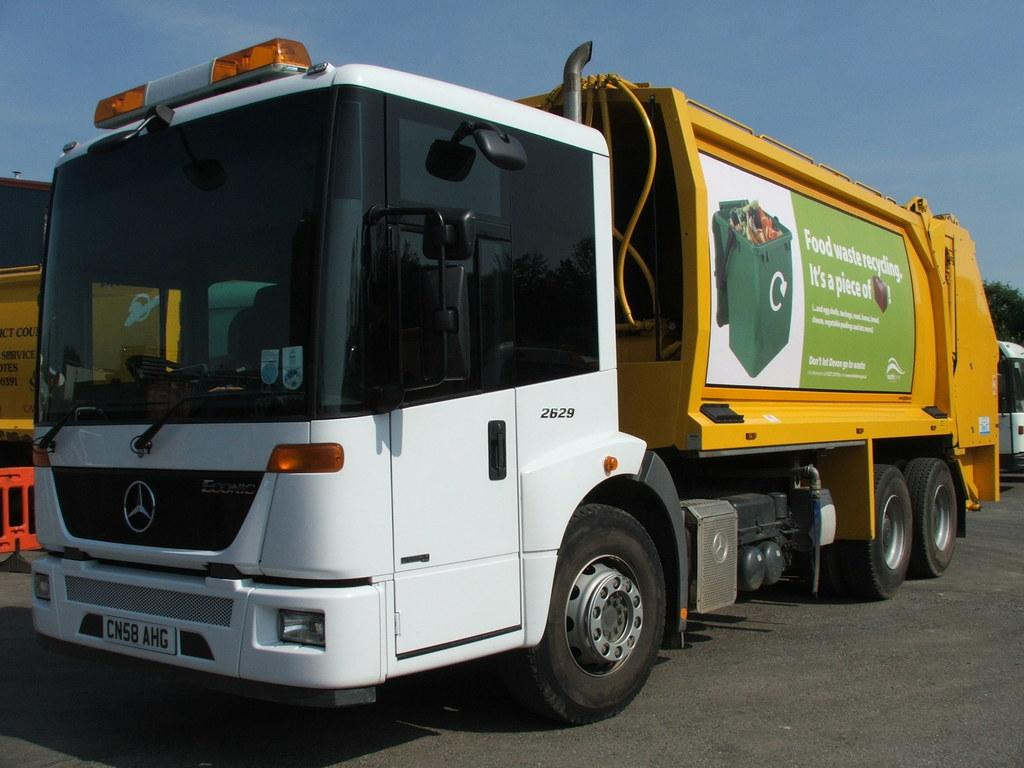<image>
Share a concise interpretation of the image provided. A yellow truck has a sign on the side about food waste recycling. 